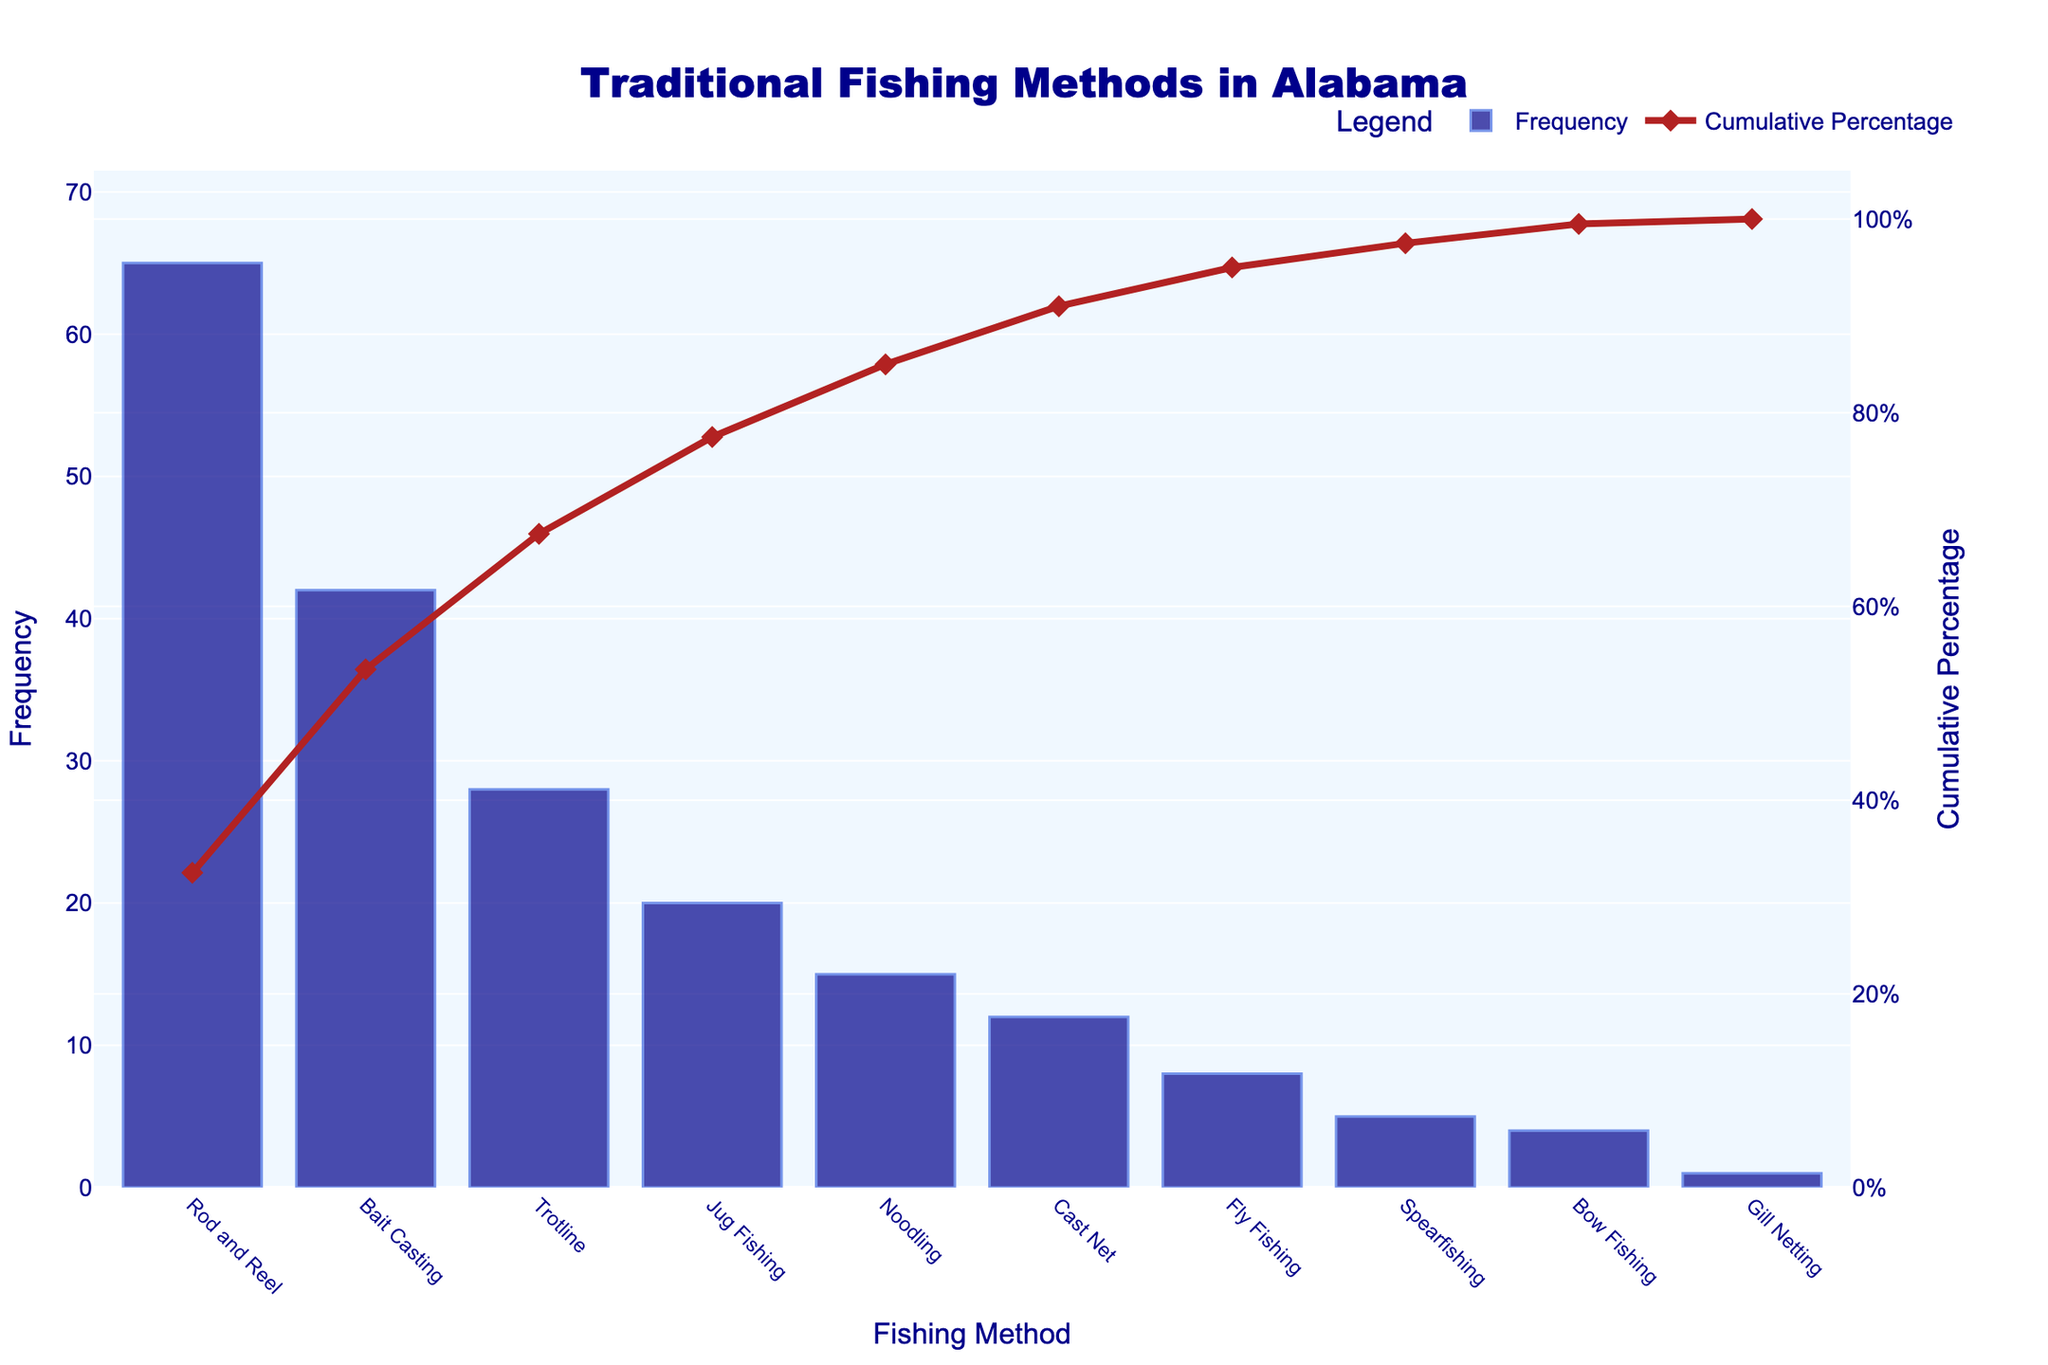What's the most frequently used traditional fishing method in Alabama? The most frequently used method can be identified from the highest bar in the chart, which is labeled as "Rod and Reel" with a frequency of 65.
Answer: Rod and Reel Which fishing methods cumulatively make up at least 50% of the total frequency? To find this, look at the cumulative percentage line. Rod and Reel, Bait Casting, and Trotline combined surpass the 50% mark.
Answer: Rod and Reel, Bait Casting, Trotline How many fishing methods are shown in the chart? Count the distinct bars or labels on the x-axis. There are 10 labels (fishing methods) on the chart.
Answer: 10 What's the cumulative percentage after the first three fishing methods? Look at the cumulative percentage after "Trotline," which is the third method. The line reaches 80.8%.
Answer: 80.8% Which fishing method has the lowest frequency? Identify the shortest bar, which corresponds to Gill Netting, with a frequency of 1.
Answer: Gill Netting How does the frequency of Noodling compare to Jug Fishing? Noodling has a frequency of 15, while Jug Fishing has a frequency of 20. Therefore, Jug Fishing is more frequent.
Answer: Jug Fishing is more frequent What is the cumulative percentage of the first five fishing methods? Add the frequencies of the first five methods (Rod and Reel, Bait Casting, Trotline, Jug Fishing, and Noodling), then calculate the cumulative percentage: (65 + 42 + 28 + 20 + 15) / 200 = 85%.
Answer: 85% What is the frequency difference between the highest and lowest methods? Subtract the frequency of Gill Netting (1) from Rod and Reel (65): 65 - 1 = 64.
Answer: 64 Which fishing methods collectively achieve at least 90% cumulative percentage? Find the methods where the cumulative line reaches or exceeds 90%. This includes Rod and Reel, Bait Casting, Trotline, Jug Fishing, Noodling, and Cast Net.
Answer: Rod and Reel, Bait Casting, Trotline, Jug Fishing, Noodling, Cast Net What's the color used for marking the line trace of the cumulative percentage? The cumulative percentage line is represented in firebrick color, both line and markers.
Answer: Firebrick 